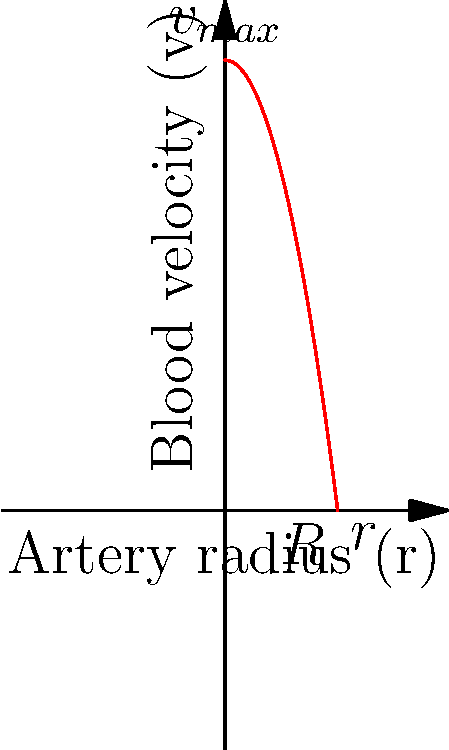In modeling blood flow through arteries, which equation best describes the velocity profile shown in the graph, and how could this information be used to optimize your cloud-based fluid dynamics simulation platform for healthcare applications? To answer this question, let's break it down step-by-step:

1. The graph shows a parabolic velocity profile, which is characteristic of laminar flow in a cylindrical pipe (or artery in this case).

2. The equation that describes this parabolic velocity profile in a pipe is the Hagen-Poiseuille equation:

   $$v(r) = v_{max}\left(1 - \frac{r^2}{R^2}\right)$$

   Where:
   - $v(r)$ is the velocity at a distance $r$ from the center of the pipe
   - $v_{max}$ is the maximum velocity at the center of the pipe
   - $R$ is the radius of the pipe

3. This equation accurately represents the velocity distribution shown in the graph, where the velocity is maximum at the center (r = 0) and zero at the walls (r = R).

4. To optimize a cloud-based fluid dynamics simulation platform for healthcare applications:

   a) Implement the Hagen-Poiseuille equation in the simulation software to accurately model blood flow in arteries.
   
   b) Utilize cloud computing resources to perform parallel computations, allowing for more complex and realistic simulations of arterial networks.
   
   c) Develop a user-friendly interface that allows healthcare professionals to input patient-specific artery dimensions and blood properties.
   
   d) Incorporate machine learning algorithms to predict potential arterial blockages or abnormalities based on simulated flow patterns.
   
   e) Provide real-time visualization of blood flow simulations, leveraging the cloud's processing power for quick rendering and analysis.
   
   f) Offer secure data storage and sharing capabilities for patient data and simulation results, ensuring compliance with healthcare data regulations.

By implementing these features, the cloud-based platform can offer powerful, accurate, and accessible blood flow simulations for healthcare professionals, potentially improving diagnosis and treatment planning for cardiovascular conditions.
Answer: Hagen-Poiseuille equation: $v(r) = v_{max}(1 - \frac{r^2}{R^2})$ 